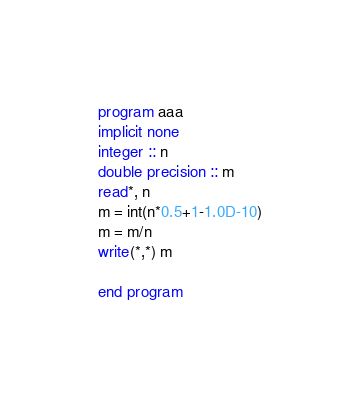<code> <loc_0><loc_0><loc_500><loc_500><_FORTRAN_>program aaa
implicit none
integer :: n
double precision :: m
read*, n
m = int(n*0.5+1-1.0D-10)
m = m/n
write(*,*) m

end program</code> 